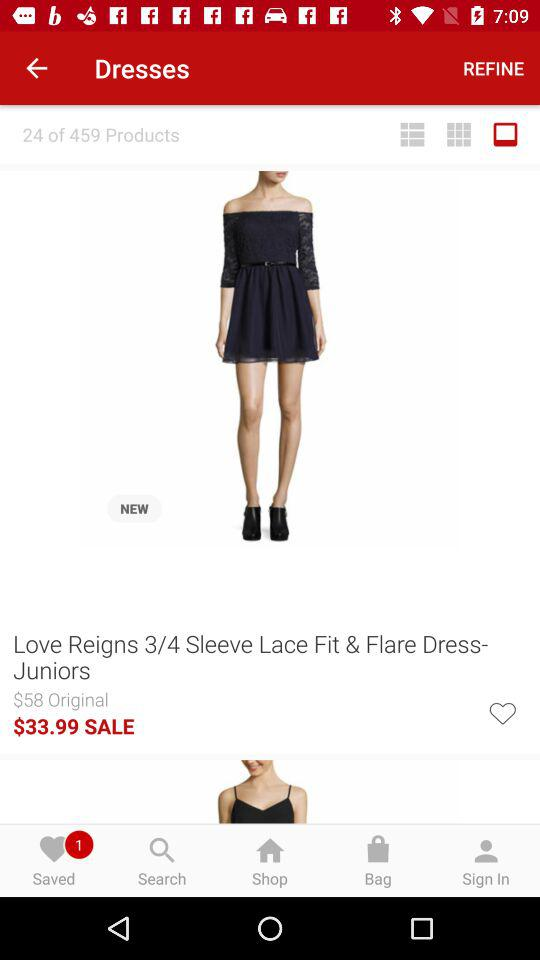What is the total number of products? The total number of products is 459. 